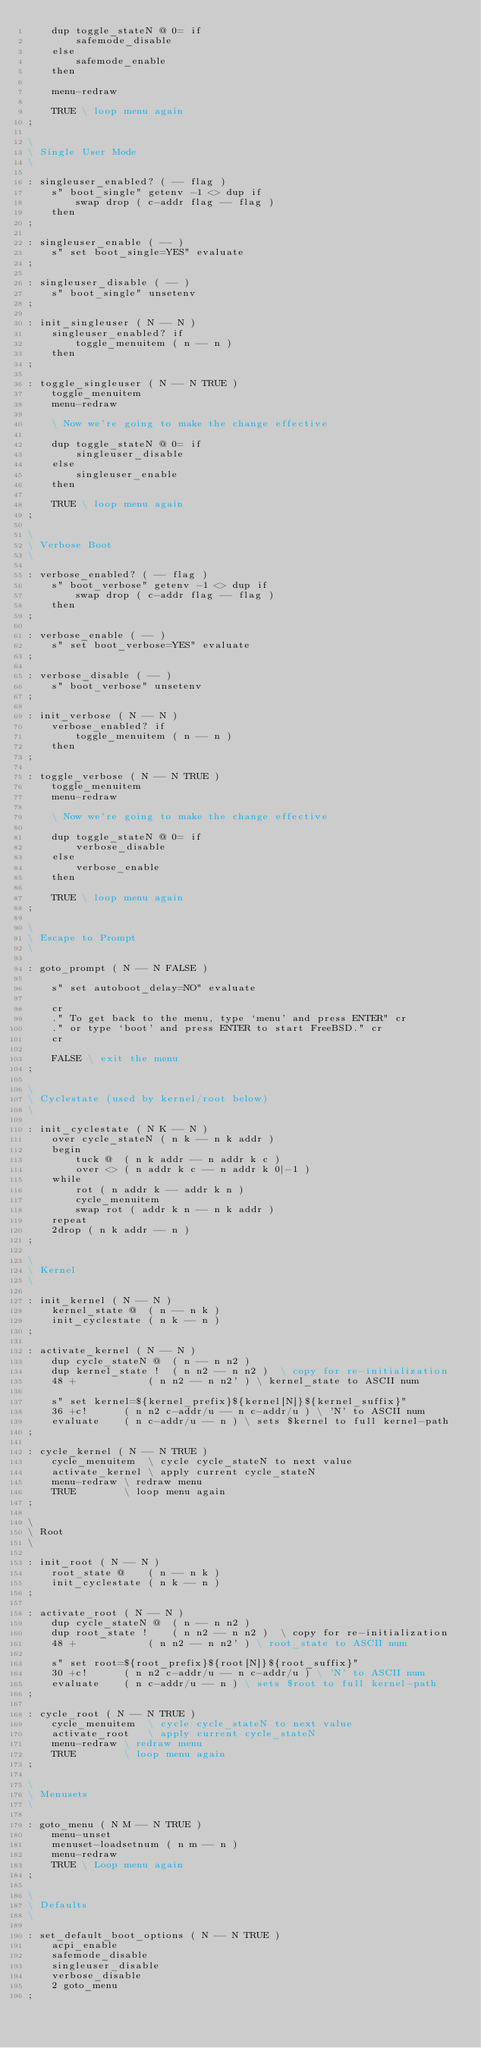Convert code to text. <code><loc_0><loc_0><loc_500><loc_500><_Forth_>	dup toggle_stateN @ 0= if
		safemode_disable
	else
		safemode_enable
	then

	menu-redraw

	TRUE \ loop menu again
;

\ 
\ Single User Mode
\ 

: singleuser_enabled? ( -- flag )
	s" boot_single" getenv -1 <> dup if
		swap drop ( c-addr flag -- flag )
	then
;

: singleuser_enable ( -- )
	s" set boot_single=YES" evaluate
;

: singleuser_disable ( -- )
	s" boot_single" unsetenv
;

: init_singleuser ( N -- N )
	singleuser_enabled? if
		toggle_menuitem ( n -- n )
	then
;

: toggle_singleuser ( N -- N TRUE )
	toggle_menuitem
	menu-redraw

	\ Now we're going to make the change effective

	dup toggle_stateN @ 0= if
		singleuser_disable
	else
		singleuser_enable
	then

	TRUE \ loop menu again
;

\ 
\ Verbose Boot
\ 

: verbose_enabled? ( -- flag )
	s" boot_verbose" getenv -1 <> dup if
		swap drop ( c-addr flag -- flag )
	then
;

: verbose_enable ( -- )
	s" set boot_verbose=YES" evaluate
;

: verbose_disable ( -- )
	s" boot_verbose" unsetenv
;

: init_verbose ( N -- N )
	verbose_enabled? if
		toggle_menuitem ( n -- n )
	then
;

: toggle_verbose ( N -- N TRUE )
	toggle_menuitem
	menu-redraw

	\ Now we're going to make the change effective

	dup toggle_stateN @ 0= if
		verbose_disable
	else
		verbose_enable
	then

	TRUE \ loop menu again
;

\ 
\ Escape to Prompt
\ 

: goto_prompt ( N -- N FALSE )

	s" set autoboot_delay=NO" evaluate

	cr
	." To get back to the menu, type `menu' and press ENTER" cr
	." or type `boot' and press ENTER to start FreeBSD." cr
	cr

	FALSE \ exit the menu
;

\ 
\ Cyclestate (used by kernel/root below)
\ 

: init_cyclestate ( N K -- N )
	over cycle_stateN ( n k -- n k addr )
	begin
		tuck @  ( n k addr -- n addr k c )
		over <> ( n addr k c -- n addr k 0|-1 )
	while
		rot ( n addr k -- addr k n )
		cycle_menuitem
		swap rot ( addr k n -- n k addr )
	repeat
	2drop ( n k addr -- n )
;

\
\ Kernel
\ 

: init_kernel ( N -- N )
	kernel_state @  ( n -- n k )
	init_cyclestate ( n k -- n )
;

: activate_kernel ( N -- N )
	dup cycle_stateN @	( n -- n n2 )
	dup kernel_state !	( n n2 -- n n2 )  \ copy for re-initialization
	48 +			( n n2 -- n n2' ) \ kernel_state to ASCII num

	s" set kernel=${kernel_prefix}${kernel[N]}${kernel_suffix}"
	36 +c!		( n n2 c-addr/u -- n c-addr/u ) \ 'N' to ASCII num
	evaluate	( n c-addr/u -- n ) \ sets $kernel to full kernel-path
;

: cycle_kernel ( N -- N TRUE )
	cycle_menuitem	\ cycle cycle_stateN to next value
	activate_kernel \ apply current cycle_stateN
	menu-redraw	\ redraw menu
	TRUE		\ loop menu again
;

\ 
\ Root
\ 

: init_root ( N -- N )
	root_state @    ( n -- n k )
	init_cyclestate ( n k -- n )
;

: activate_root ( N -- N )
	dup cycle_stateN @	( n -- n n2 )
	dup root_state !	( n n2 -- n n2 )  \ copy for re-initialization
	48 +			( n n2 -- n n2' ) \ root_state to ASCII num

	s" set root=${root_prefix}${root[N]}${root_suffix}"
	30 +c!		( n n2 c-addr/u -- n c-addr/u ) \ 'N' to ASCII num
	evaluate	( n c-addr/u -- n ) \ sets $root to full kernel-path
;

: cycle_root ( N -- N TRUE )
	cycle_menuitem	\ cycle cycle_stateN to next value
	activate_root	\ apply current cycle_stateN
	menu-redraw	\ redraw menu
	TRUE		\ loop menu again
;

\ 
\ Menusets
\ 

: goto_menu ( N M -- N TRUE )
	menu-unset
	menuset-loadsetnum ( n m -- n )
	menu-redraw
	TRUE \ Loop menu again
;

\ 
\ Defaults
\ 

: set_default_boot_options ( N -- N TRUE )
	acpi_enable
	safemode_disable
	singleuser_disable
	verbose_disable
	2 goto_menu
;
</code> 